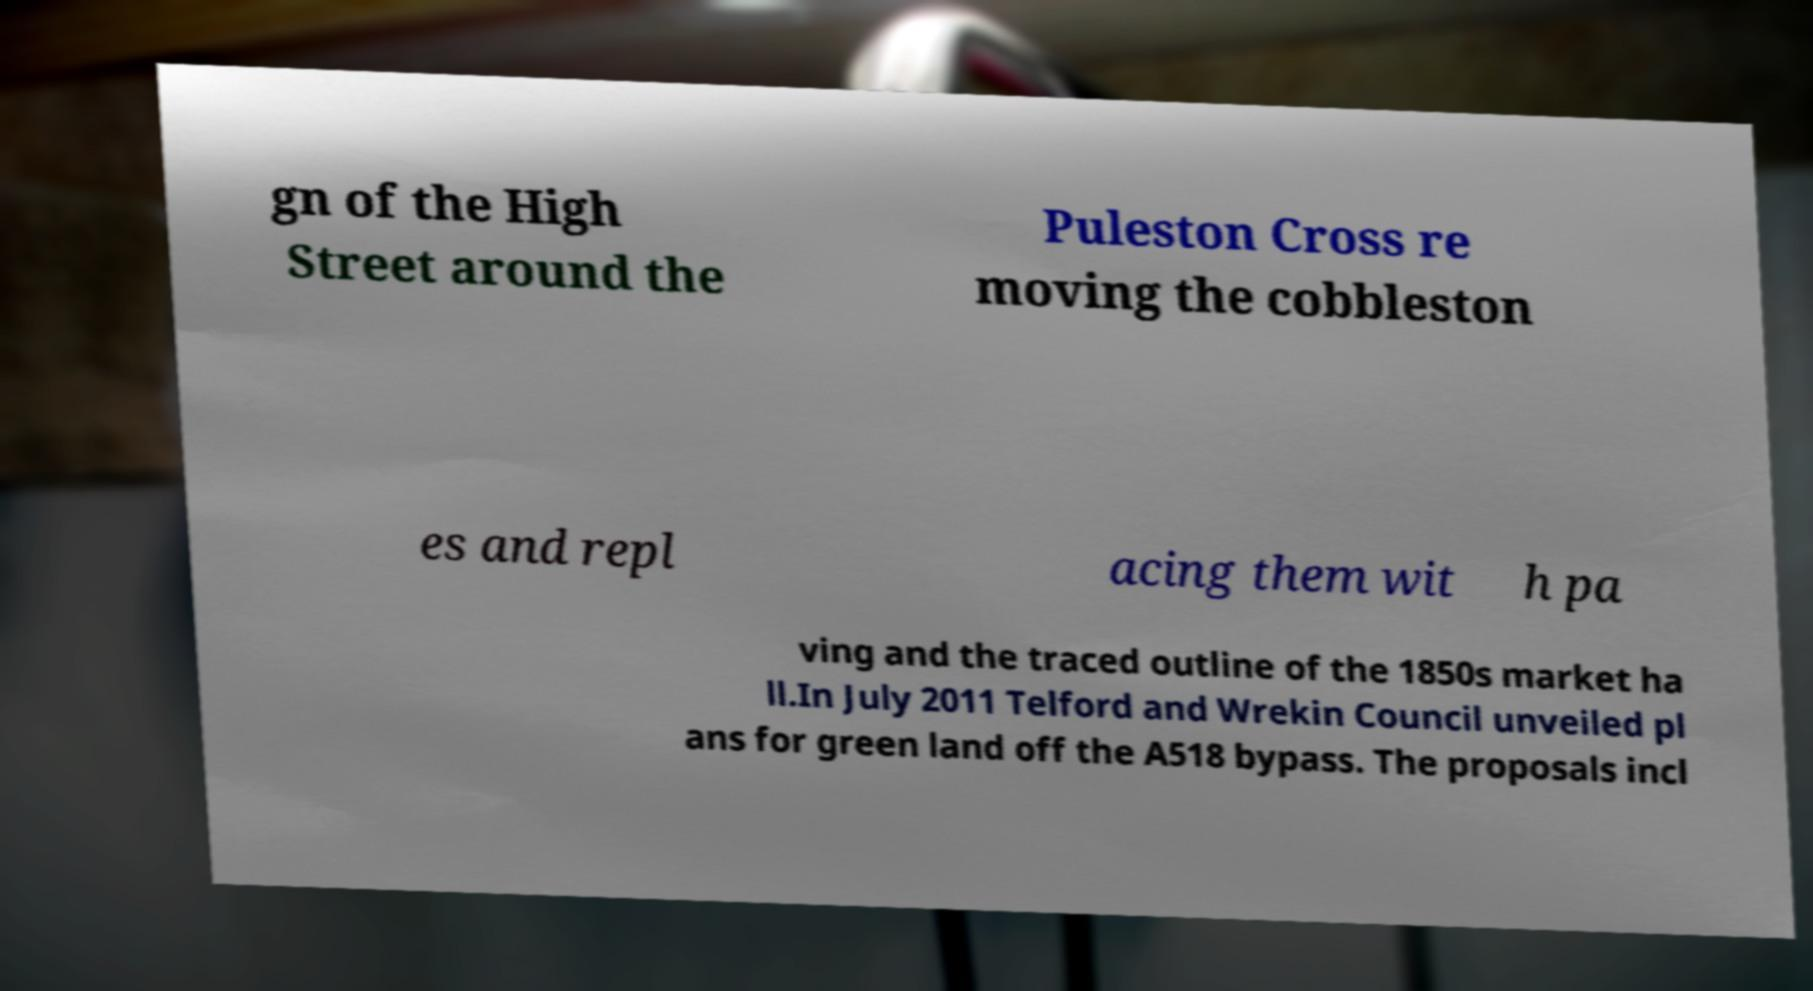Could you assist in decoding the text presented in this image and type it out clearly? gn of the High Street around the Puleston Cross re moving the cobbleston es and repl acing them wit h pa ving and the traced outline of the 1850s market ha ll.In July 2011 Telford and Wrekin Council unveiled pl ans for green land off the A518 bypass. The proposals incl 